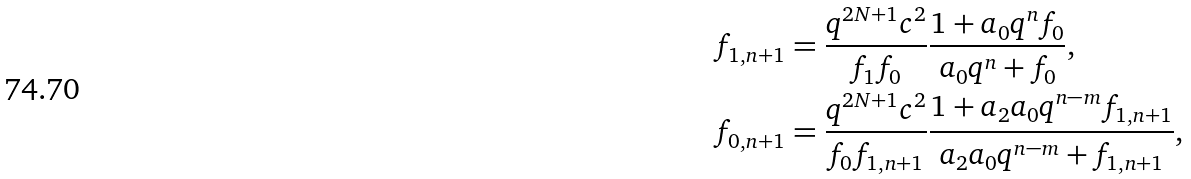Convert formula to latex. <formula><loc_0><loc_0><loc_500><loc_500>& f _ { 1 , n + 1 } = \frac { q ^ { 2 N + 1 } c ^ { 2 } } { f _ { 1 } f _ { 0 } } \frac { 1 + a _ { 0 } q ^ { n } f _ { 0 } } { a _ { 0 } q ^ { n } + f _ { 0 } } , \\ & f _ { 0 , n + 1 } = \frac { q ^ { 2 N + 1 } c ^ { 2 } } { f _ { 0 } f _ { 1 , n + 1 } } \frac { 1 + a _ { 2 } a _ { 0 } q ^ { n - m } f _ { 1 , n + 1 } } { a _ { 2 } a _ { 0 } q ^ { n - m } + f _ { 1 , n + 1 } } ,</formula> 